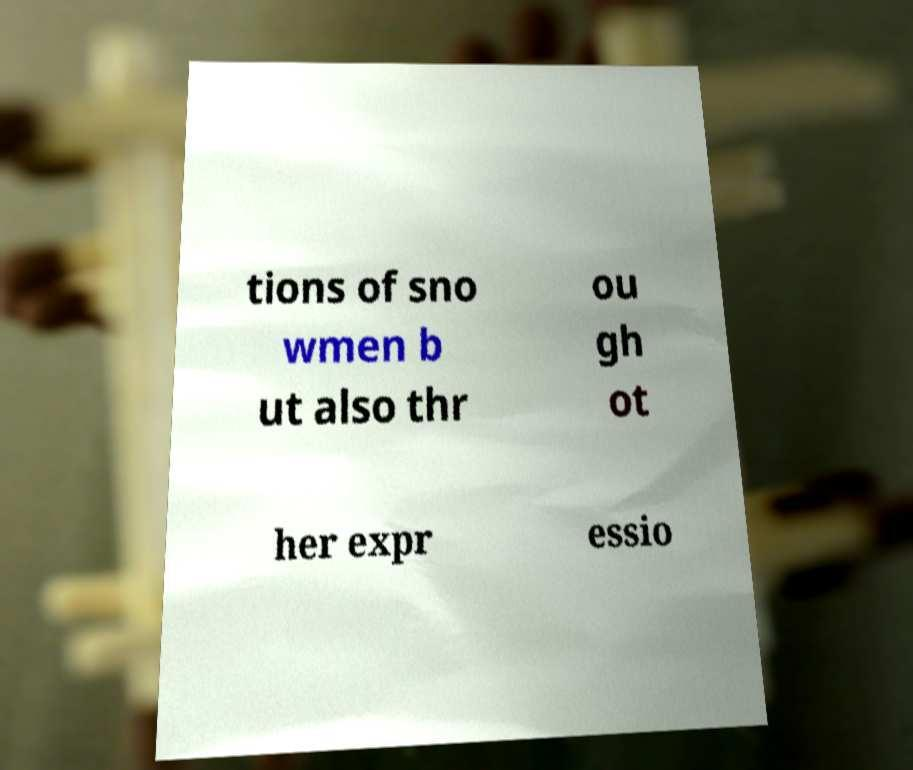Can you read and provide the text displayed in the image?This photo seems to have some interesting text. Can you extract and type it out for me? tions of sno wmen b ut also thr ou gh ot her expr essio 